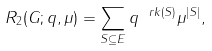Convert formula to latex. <formula><loc_0><loc_0><loc_500><loc_500>R _ { 2 } ( G ; q , \mu ) = \sum _ { S \subseteq E } q ^ { \ r k ( S ) } \mu ^ { | S | } ,</formula> 